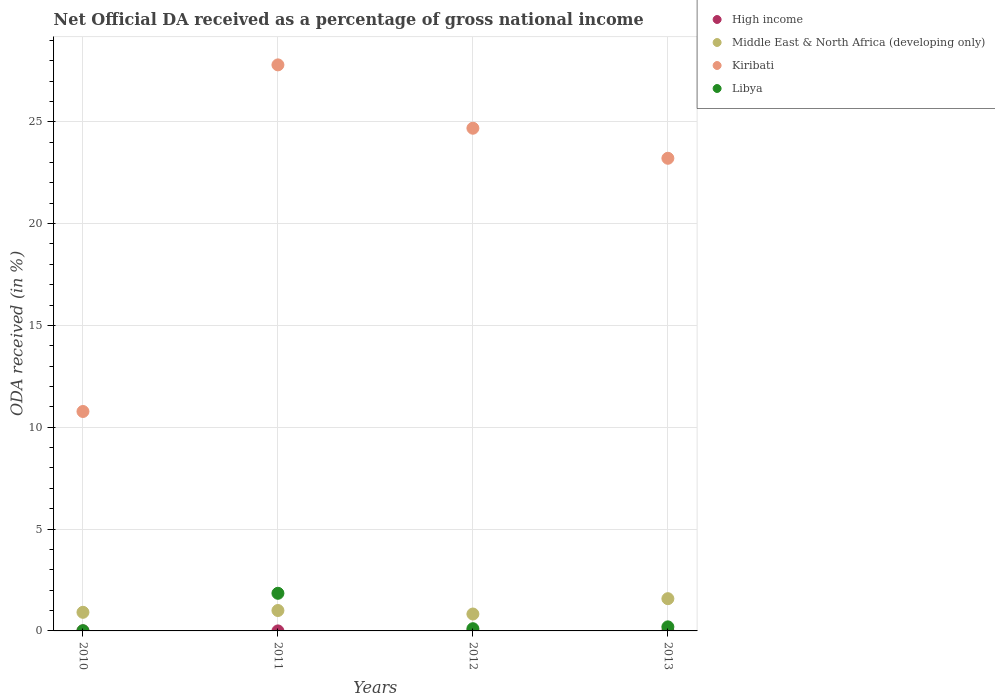How many different coloured dotlines are there?
Make the answer very short. 4. What is the net official DA received in Libya in 2012?
Your answer should be compact. 0.11. Across all years, what is the maximum net official DA received in High income?
Provide a succinct answer. 0. Across all years, what is the minimum net official DA received in Kiribati?
Give a very brief answer. 10.77. What is the total net official DA received in Middle East & North Africa (developing only) in the graph?
Offer a very short reply. 4.33. What is the difference between the net official DA received in High income in 2011 and that in 2013?
Your answer should be compact. 0. What is the difference between the net official DA received in Middle East & North Africa (developing only) in 2011 and the net official DA received in Libya in 2012?
Ensure brevity in your answer.  0.89. What is the average net official DA received in High income per year?
Offer a very short reply. 0. In the year 2013, what is the difference between the net official DA received in Kiribati and net official DA received in High income?
Keep it short and to the point. 23.21. In how many years, is the net official DA received in Kiribati greater than 4 %?
Your answer should be compact. 4. What is the ratio of the net official DA received in High income in 2010 to that in 2011?
Keep it short and to the point. 2.35. Is the net official DA received in Kiribati in 2012 less than that in 2013?
Your response must be concise. No. What is the difference between the highest and the second highest net official DA received in Middle East & North Africa (developing only)?
Offer a terse response. 0.58. What is the difference between the highest and the lowest net official DA received in High income?
Make the answer very short. 0. In how many years, is the net official DA received in Libya greater than the average net official DA received in Libya taken over all years?
Offer a terse response. 1. Is it the case that in every year, the sum of the net official DA received in Kiribati and net official DA received in Libya  is greater than the net official DA received in Middle East & North Africa (developing only)?
Your response must be concise. Yes. Does the net official DA received in Kiribati monotonically increase over the years?
Give a very brief answer. No. How many dotlines are there?
Keep it short and to the point. 4. How many years are there in the graph?
Your answer should be very brief. 4. Does the graph contain any zero values?
Keep it short and to the point. No. Where does the legend appear in the graph?
Give a very brief answer. Top right. How many legend labels are there?
Provide a succinct answer. 4. What is the title of the graph?
Ensure brevity in your answer.  Net Official DA received as a percentage of gross national income. Does "Euro area" appear as one of the legend labels in the graph?
Your answer should be compact. No. What is the label or title of the Y-axis?
Offer a very short reply. ODA received (in %). What is the ODA received (in %) in High income in 2010?
Make the answer very short. 0. What is the ODA received (in %) in Middle East & North Africa (developing only) in 2010?
Your response must be concise. 0.91. What is the ODA received (in %) of Kiribati in 2010?
Provide a succinct answer. 10.77. What is the ODA received (in %) of Libya in 2010?
Offer a very short reply. 0.01. What is the ODA received (in %) in High income in 2011?
Offer a very short reply. 0. What is the ODA received (in %) in Middle East & North Africa (developing only) in 2011?
Your response must be concise. 1. What is the ODA received (in %) in Kiribati in 2011?
Give a very brief answer. 27.79. What is the ODA received (in %) of Libya in 2011?
Offer a very short reply. 1.85. What is the ODA received (in %) of High income in 2012?
Keep it short and to the point. 0. What is the ODA received (in %) of Middle East & North Africa (developing only) in 2012?
Keep it short and to the point. 0.83. What is the ODA received (in %) of Kiribati in 2012?
Ensure brevity in your answer.  24.68. What is the ODA received (in %) of Libya in 2012?
Give a very brief answer. 0.11. What is the ODA received (in %) of High income in 2013?
Keep it short and to the point. 0. What is the ODA received (in %) in Middle East & North Africa (developing only) in 2013?
Your response must be concise. 1.58. What is the ODA received (in %) in Kiribati in 2013?
Your response must be concise. 23.21. What is the ODA received (in %) of Libya in 2013?
Make the answer very short. 0.2. Across all years, what is the maximum ODA received (in %) of High income?
Your answer should be compact. 0. Across all years, what is the maximum ODA received (in %) of Middle East & North Africa (developing only)?
Give a very brief answer. 1.58. Across all years, what is the maximum ODA received (in %) in Kiribati?
Give a very brief answer. 27.79. Across all years, what is the maximum ODA received (in %) of Libya?
Keep it short and to the point. 1.85. Across all years, what is the minimum ODA received (in %) of High income?
Your response must be concise. 0. Across all years, what is the minimum ODA received (in %) in Middle East & North Africa (developing only)?
Offer a very short reply. 0.83. Across all years, what is the minimum ODA received (in %) in Kiribati?
Provide a succinct answer. 10.77. Across all years, what is the minimum ODA received (in %) of Libya?
Keep it short and to the point. 0.01. What is the total ODA received (in %) in High income in the graph?
Your answer should be very brief. 0. What is the total ODA received (in %) of Middle East & North Africa (developing only) in the graph?
Keep it short and to the point. 4.33. What is the total ODA received (in %) in Kiribati in the graph?
Give a very brief answer. 86.46. What is the total ODA received (in %) in Libya in the graph?
Make the answer very short. 2.17. What is the difference between the ODA received (in %) in High income in 2010 and that in 2011?
Make the answer very short. 0. What is the difference between the ODA received (in %) of Middle East & North Africa (developing only) in 2010 and that in 2011?
Offer a terse response. -0.09. What is the difference between the ODA received (in %) of Kiribati in 2010 and that in 2011?
Provide a succinct answer. -17.02. What is the difference between the ODA received (in %) in Libya in 2010 and that in 2011?
Keep it short and to the point. -1.84. What is the difference between the ODA received (in %) of High income in 2010 and that in 2012?
Keep it short and to the point. 0. What is the difference between the ODA received (in %) in Middle East & North Africa (developing only) in 2010 and that in 2012?
Your response must be concise. 0.08. What is the difference between the ODA received (in %) of Kiribati in 2010 and that in 2012?
Your answer should be compact. -13.91. What is the difference between the ODA received (in %) in Libya in 2010 and that in 2012?
Provide a short and direct response. -0.1. What is the difference between the ODA received (in %) in High income in 2010 and that in 2013?
Provide a succinct answer. 0. What is the difference between the ODA received (in %) of Middle East & North Africa (developing only) in 2010 and that in 2013?
Your response must be concise. -0.67. What is the difference between the ODA received (in %) of Kiribati in 2010 and that in 2013?
Provide a succinct answer. -12.43. What is the difference between the ODA received (in %) in Libya in 2010 and that in 2013?
Make the answer very short. -0.19. What is the difference between the ODA received (in %) of Middle East & North Africa (developing only) in 2011 and that in 2012?
Provide a short and direct response. 0.17. What is the difference between the ODA received (in %) of Kiribati in 2011 and that in 2012?
Provide a short and direct response. 3.11. What is the difference between the ODA received (in %) in Libya in 2011 and that in 2012?
Give a very brief answer. 1.74. What is the difference between the ODA received (in %) of High income in 2011 and that in 2013?
Offer a terse response. 0. What is the difference between the ODA received (in %) in Middle East & North Africa (developing only) in 2011 and that in 2013?
Provide a short and direct response. -0.58. What is the difference between the ODA received (in %) in Kiribati in 2011 and that in 2013?
Your response must be concise. 4.59. What is the difference between the ODA received (in %) of Libya in 2011 and that in 2013?
Your answer should be compact. 1.65. What is the difference between the ODA received (in %) of High income in 2012 and that in 2013?
Provide a succinct answer. 0. What is the difference between the ODA received (in %) in Middle East & North Africa (developing only) in 2012 and that in 2013?
Your response must be concise. -0.75. What is the difference between the ODA received (in %) of Kiribati in 2012 and that in 2013?
Make the answer very short. 1.48. What is the difference between the ODA received (in %) in Libya in 2012 and that in 2013?
Provide a short and direct response. -0.09. What is the difference between the ODA received (in %) of High income in 2010 and the ODA received (in %) of Middle East & North Africa (developing only) in 2011?
Ensure brevity in your answer.  -1. What is the difference between the ODA received (in %) in High income in 2010 and the ODA received (in %) in Kiribati in 2011?
Give a very brief answer. -27.79. What is the difference between the ODA received (in %) in High income in 2010 and the ODA received (in %) in Libya in 2011?
Offer a very short reply. -1.85. What is the difference between the ODA received (in %) of Middle East & North Africa (developing only) in 2010 and the ODA received (in %) of Kiribati in 2011?
Offer a very short reply. -26.88. What is the difference between the ODA received (in %) in Middle East & North Africa (developing only) in 2010 and the ODA received (in %) in Libya in 2011?
Your response must be concise. -0.93. What is the difference between the ODA received (in %) in Kiribati in 2010 and the ODA received (in %) in Libya in 2011?
Provide a short and direct response. 8.93. What is the difference between the ODA received (in %) of High income in 2010 and the ODA received (in %) of Middle East & North Africa (developing only) in 2012?
Provide a short and direct response. -0.83. What is the difference between the ODA received (in %) of High income in 2010 and the ODA received (in %) of Kiribati in 2012?
Provide a succinct answer. -24.68. What is the difference between the ODA received (in %) of High income in 2010 and the ODA received (in %) of Libya in 2012?
Provide a short and direct response. -0.11. What is the difference between the ODA received (in %) of Middle East & North Africa (developing only) in 2010 and the ODA received (in %) of Kiribati in 2012?
Give a very brief answer. -23.77. What is the difference between the ODA received (in %) of Middle East & North Africa (developing only) in 2010 and the ODA received (in %) of Libya in 2012?
Offer a very short reply. 0.81. What is the difference between the ODA received (in %) in Kiribati in 2010 and the ODA received (in %) in Libya in 2012?
Provide a short and direct response. 10.67. What is the difference between the ODA received (in %) of High income in 2010 and the ODA received (in %) of Middle East & North Africa (developing only) in 2013?
Make the answer very short. -1.58. What is the difference between the ODA received (in %) of High income in 2010 and the ODA received (in %) of Kiribati in 2013?
Offer a very short reply. -23.21. What is the difference between the ODA received (in %) of High income in 2010 and the ODA received (in %) of Libya in 2013?
Offer a terse response. -0.2. What is the difference between the ODA received (in %) of Middle East & North Africa (developing only) in 2010 and the ODA received (in %) of Kiribati in 2013?
Provide a succinct answer. -22.29. What is the difference between the ODA received (in %) in Middle East & North Africa (developing only) in 2010 and the ODA received (in %) in Libya in 2013?
Make the answer very short. 0.72. What is the difference between the ODA received (in %) of Kiribati in 2010 and the ODA received (in %) of Libya in 2013?
Keep it short and to the point. 10.58. What is the difference between the ODA received (in %) in High income in 2011 and the ODA received (in %) in Middle East & North Africa (developing only) in 2012?
Make the answer very short. -0.83. What is the difference between the ODA received (in %) of High income in 2011 and the ODA received (in %) of Kiribati in 2012?
Provide a succinct answer. -24.68. What is the difference between the ODA received (in %) in High income in 2011 and the ODA received (in %) in Libya in 2012?
Offer a very short reply. -0.11. What is the difference between the ODA received (in %) of Middle East & North Africa (developing only) in 2011 and the ODA received (in %) of Kiribati in 2012?
Your response must be concise. -23.68. What is the difference between the ODA received (in %) of Middle East & North Africa (developing only) in 2011 and the ODA received (in %) of Libya in 2012?
Provide a succinct answer. 0.89. What is the difference between the ODA received (in %) in Kiribati in 2011 and the ODA received (in %) in Libya in 2012?
Give a very brief answer. 27.68. What is the difference between the ODA received (in %) of High income in 2011 and the ODA received (in %) of Middle East & North Africa (developing only) in 2013?
Your answer should be compact. -1.58. What is the difference between the ODA received (in %) in High income in 2011 and the ODA received (in %) in Kiribati in 2013?
Ensure brevity in your answer.  -23.21. What is the difference between the ODA received (in %) of High income in 2011 and the ODA received (in %) of Libya in 2013?
Offer a very short reply. -0.2. What is the difference between the ODA received (in %) of Middle East & North Africa (developing only) in 2011 and the ODA received (in %) of Kiribati in 2013?
Keep it short and to the point. -22.21. What is the difference between the ODA received (in %) in Middle East & North Africa (developing only) in 2011 and the ODA received (in %) in Libya in 2013?
Provide a short and direct response. 0.8. What is the difference between the ODA received (in %) in Kiribati in 2011 and the ODA received (in %) in Libya in 2013?
Give a very brief answer. 27.59. What is the difference between the ODA received (in %) of High income in 2012 and the ODA received (in %) of Middle East & North Africa (developing only) in 2013?
Offer a terse response. -1.58. What is the difference between the ODA received (in %) of High income in 2012 and the ODA received (in %) of Kiribati in 2013?
Ensure brevity in your answer.  -23.21. What is the difference between the ODA received (in %) of High income in 2012 and the ODA received (in %) of Libya in 2013?
Your answer should be compact. -0.2. What is the difference between the ODA received (in %) in Middle East & North Africa (developing only) in 2012 and the ODA received (in %) in Kiribati in 2013?
Ensure brevity in your answer.  -22.38. What is the difference between the ODA received (in %) of Middle East & North Africa (developing only) in 2012 and the ODA received (in %) of Libya in 2013?
Make the answer very short. 0.63. What is the difference between the ODA received (in %) in Kiribati in 2012 and the ODA received (in %) in Libya in 2013?
Your answer should be very brief. 24.48. What is the average ODA received (in %) of High income per year?
Your answer should be very brief. 0. What is the average ODA received (in %) in Middle East & North Africa (developing only) per year?
Offer a very short reply. 1.08. What is the average ODA received (in %) in Kiribati per year?
Give a very brief answer. 21.61. What is the average ODA received (in %) of Libya per year?
Your answer should be compact. 0.54. In the year 2010, what is the difference between the ODA received (in %) of High income and ODA received (in %) of Middle East & North Africa (developing only)?
Make the answer very short. -0.91. In the year 2010, what is the difference between the ODA received (in %) in High income and ODA received (in %) in Kiribati?
Give a very brief answer. -10.77. In the year 2010, what is the difference between the ODA received (in %) of High income and ODA received (in %) of Libya?
Your answer should be very brief. -0.01. In the year 2010, what is the difference between the ODA received (in %) of Middle East & North Africa (developing only) and ODA received (in %) of Kiribati?
Keep it short and to the point. -9.86. In the year 2010, what is the difference between the ODA received (in %) of Middle East & North Africa (developing only) and ODA received (in %) of Libya?
Ensure brevity in your answer.  0.9. In the year 2010, what is the difference between the ODA received (in %) in Kiribati and ODA received (in %) in Libya?
Keep it short and to the point. 10.76. In the year 2011, what is the difference between the ODA received (in %) in High income and ODA received (in %) in Middle East & North Africa (developing only)?
Your response must be concise. -1. In the year 2011, what is the difference between the ODA received (in %) in High income and ODA received (in %) in Kiribati?
Your response must be concise. -27.79. In the year 2011, what is the difference between the ODA received (in %) of High income and ODA received (in %) of Libya?
Provide a short and direct response. -1.85. In the year 2011, what is the difference between the ODA received (in %) in Middle East & North Africa (developing only) and ODA received (in %) in Kiribati?
Your response must be concise. -26.79. In the year 2011, what is the difference between the ODA received (in %) in Middle East & North Africa (developing only) and ODA received (in %) in Libya?
Keep it short and to the point. -0.85. In the year 2011, what is the difference between the ODA received (in %) in Kiribati and ODA received (in %) in Libya?
Provide a short and direct response. 25.95. In the year 2012, what is the difference between the ODA received (in %) in High income and ODA received (in %) in Middle East & North Africa (developing only)?
Keep it short and to the point. -0.83. In the year 2012, what is the difference between the ODA received (in %) of High income and ODA received (in %) of Kiribati?
Give a very brief answer. -24.68. In the year 2012, what is the difference between the ODA received (in %) in High income and ODA received (in %) in Libya?
Ensure brevity in your answer.  -0.11. In the year 2012, what is the difference between the ODA received (in %) in Middle East & North Africa (developing only) and ODA received (in %) in Kiribati?
Provide a succinct answer. -23.85. In the year 2012, what is the difference between the ODA received (in %) in Middle East & North Africa (developing only) and ODA received (in %) in Libya?
Your answer should be very brief. 0.72. In the year 2012, what is the difference between the ODA received (in %) of Kiribati and ODA received (in %) of Libya?
Your response must be concise. 24.57. In the year 2013, what is the difference between the ODA received (in %) of High income and ODA received (in %) of Middle East & North Africa (developing only)?
Your answer should be compact. -1.58. In the year 2013, what is the difference between the ODA received (in %) of High income and ODA received (in %) of Kiribati?
Provide a short and direct response. -23.21. In the year 2013, what is the difference between the ODA received (in %) in High income and ODA received (in %) in Libya?
Your answer should be very brief. -0.2. In the year 2013, what is the difference between the ODA received (in %) of Middle East & North Africa (developing only) and ODA received (in %) of Kiribati?
Your answer should be compact. -21.62. In the year 2013, what is the difference between the ODA received (in %) in Middle East & North Africa (developing only) and ODA received (in %) in Libya?
Offer a very short reply. 1.38. In the year 2013, what is the difference between the ODA received (in %) in Kiribati and ODA received (in %) in Libya?
Offer a terse response. 23.01. What is the ratio of the ODA received (in %) in High income in 2010 to that in 2011?
Your response must be concise. 2.35. What is the ratio of the ODA received (in %) in Middle East & North Africa (developing only) in 2010 to that in 2011?
Your answer should be very brief. 0.91. What is the ratio of the ODA received (in %) in Kiribati in 2010 to that in 2011?
Keep it short and to the point. 0.39. What is the ratio of the ODA received (in %) in Libya in 2010 to that in 2011?
Provide a succinct answer. 0.01. What is the ratio of the ODA received (in %) of High income in 2010 to that in 2012?
Give a very brief answer. 3.02. What is the ratio of the ODA received (in %) of Middle East & North Africa (developing only) in 2010 to that in 2012?
Your response must be concise. 1.1. What is the ratio of the ODA received (in %) of Kiribati in 2010 to that in 2012?
Provide a succinct answer. 0.44. What is the ratio of the ODA received (in %) in Libya in 2010 to that in 2012?
Provide a short and direct response. 0.1. What is the ratio of the ODA received (in %) of High income in 2010 to that in 2013?
Make the answer very short. 3.61. What is the ratio of the ODA received (in %) in Middle East & North Africa (developing only) in 2010 to that in 2013?
Make the answer very short. 0.58. What is the ratio of the ODA received (in %) in Kiribati in 2010 to that in 2013?
Give a very brief answer. 0.46. What is the ratio of the ODA received (in %) in Libya in 2010 to that in 2013?
Provide a succinct answer. 0.06. What is the ratio of the ODA received (in %) in High income in 2011 to that in 2012?
Make the answer very short. 1.29. What is the ratio of the ODA received (in %) of Middle East & North Africa (developing only) in 2011 to that in 2012?
Offer a terse response. 1.21. What is the ratio of the ODA received (in %) in Kiribati in 2011 to that in 2012?
Your answer should be very brief. 1.13. What is the ratio of the ODA received (in %) in Libya in 2011 to that in 2012?
Offer a very short reply. 16.97. What is the ratio of the ODA received (in %) of High income in 2011 to that in 2013?
Your response must be concise. 1.54. What is the ratio of the ODA received (in %) of Middle East & North Africa (developing only) in 2011 to that in 2013?
Your response must be concise. 0.63. What is the ratio of the ODA received (in %) of Kiribati in 2011 to that in 2013?
Keep it short and to the point. 1.2. What is the ratio of the ODA received (in %) of Libya in 2011 to that in 2013?
Your response must be concise. 9.29. What is the ratio of the ODA received (in %) of High income in 2012 to that in 2013?
Ensure brevity in your answer.  1.2. What is the ratio of the ODA received (in %) of Middle East & North Africa (developing only) in 2012 to that in 2013?
Provide a succinct answer. 0.52. What is the ratio of the ODA received (in %) of Kiribati in 2012 to that in 2013?
Make the answer very short. 1.06. What is the ratio of the ODA received (in %) in Libya in 2012 to that in 2013?
Your answer should be compact. 0.55. What is the difference between the highest and the second highest ODA received (in %) of High income?
Your answer should be compact. 0. What is the difference between the highest and the second highest ODA received (in %) of Middle East & North Africa (developing only)?
Ensure brevity in your answer.  0.58. What is the difference between the highest and the second highest ODA received (in %) of Kiribati?
Provide a short and direct response. 3.11. What is the difference between the highest and the second highest ODA received (in %) in Libya?
Provide a succinct answer. 1.65. What is the difference between the highest and the lowest ODA received (in %) in High income?
Your response must be concise. 0. What is the difference between the highest and the lowest ODA received (in %) in Middle East & North Africa (developing only)?
Keep it short and to the point. 0.75. What is the difference between the highest and the lowest ODA received (in %) of Kiribati?
Provide a succinct answer. 17.02. What is the difference between the highest and the lowest ODA received (in %) in Libya?
Make the answer very short. 1.84. 